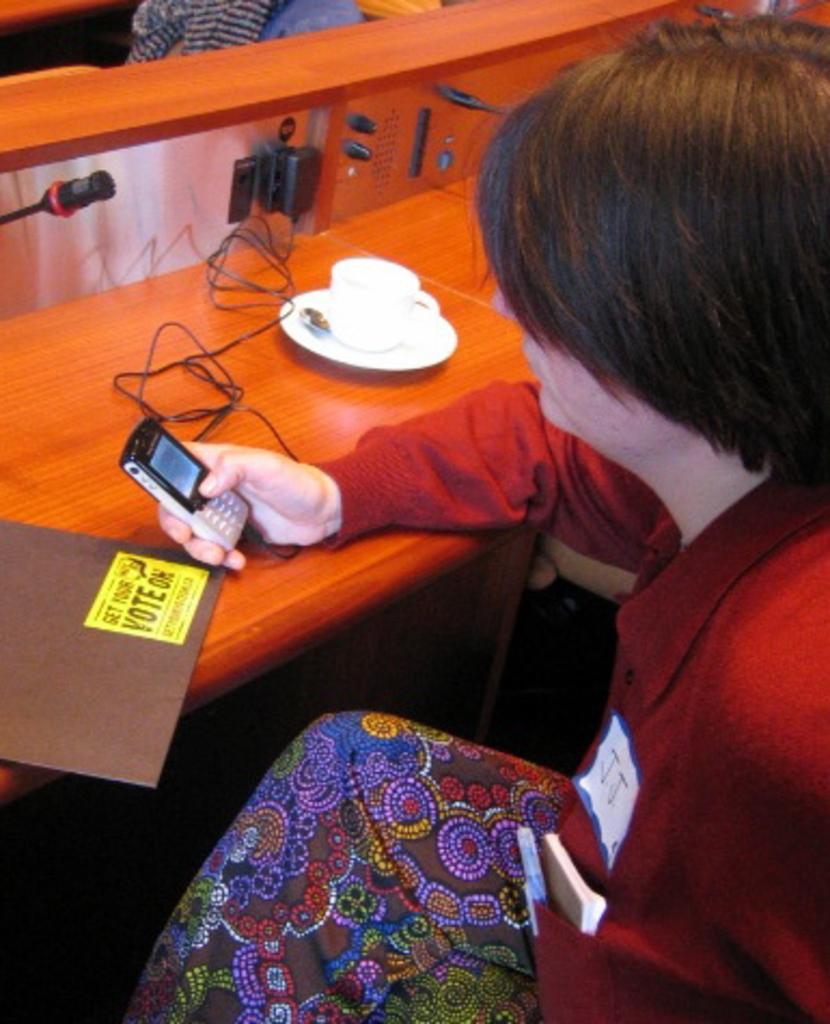Can you describe this image briefly? In the picture we can see a person sitting on the chair near the desk, to the desk we can see a wooden plank with a switchboard and charger connected to it and a person is holding a mobile phone and on the desk we can also see some file which is brown in color. 